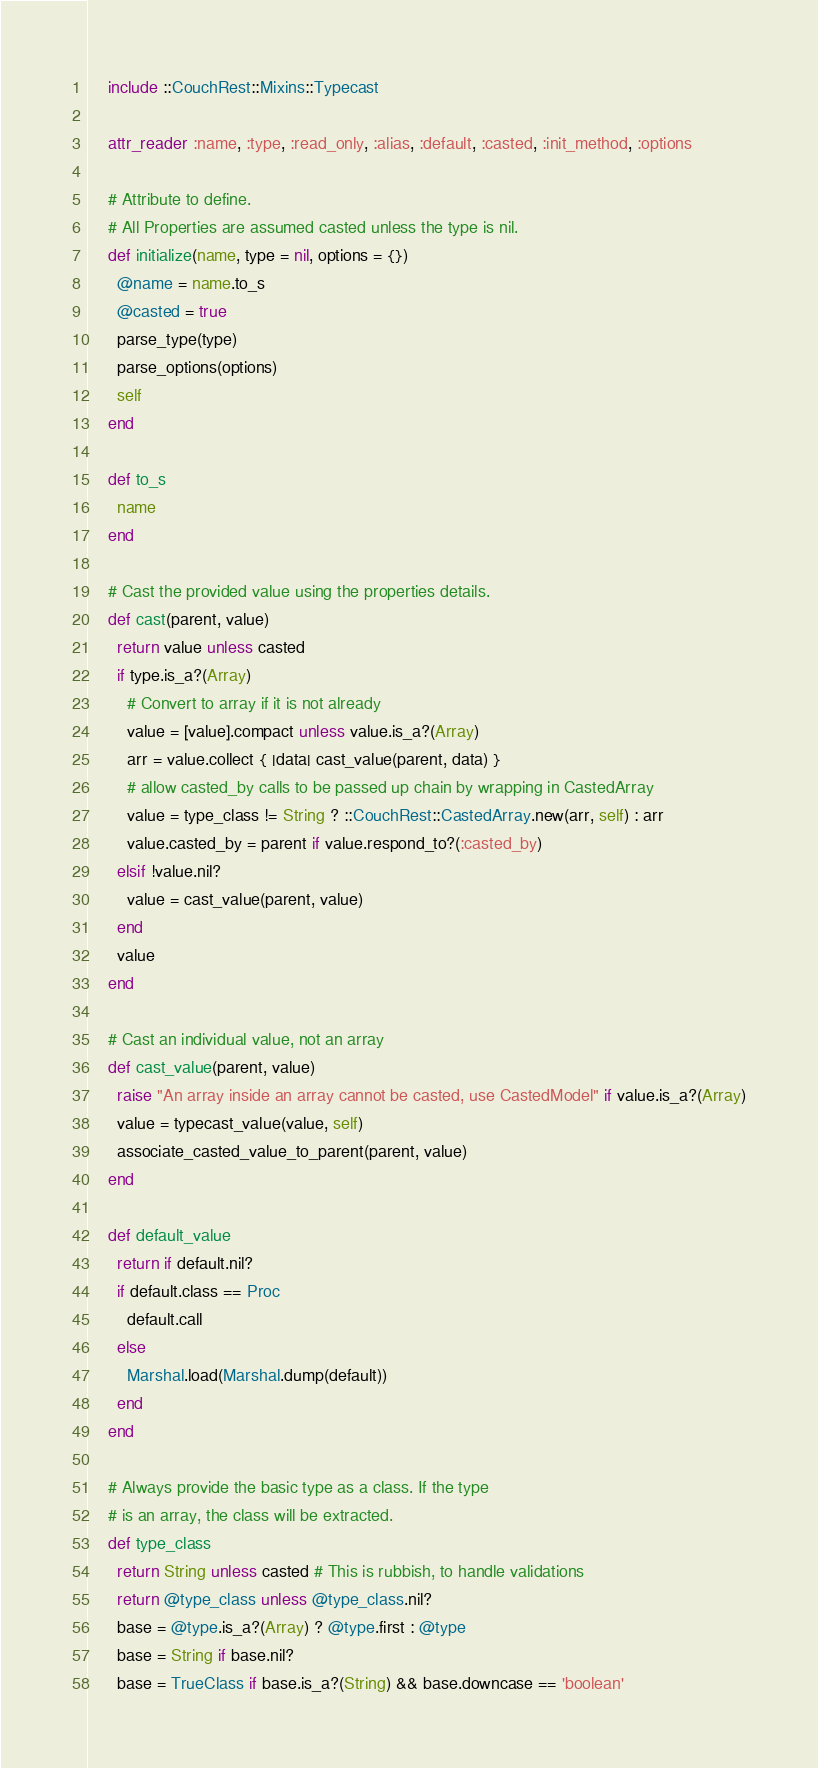Convert code to text. <code><loc_0><loc_0><loc_500><loc_500><_Ruby_>
    include ::CouchRest::Mixins::Typecast

    attr_reader :name, :type, :read_only, :alias, :default, :casted, :init_method, :options

    # Attribute to define.
    # All Properties are assumed casted unless the type is nil.
    def initialize(name, type = nil, options = {})
      @name = name.to_s
      @casted = true
      parse_type(type)
      parse_options(options)
      self
    end

    def to_s
      name
    end

    # Cast the provided value using the properties details.
    def cast(parent, value)
      return value unless casted
      if type.is_a?(Array)
        # Convert to array if it is not already
        value = [value].compact unless value.is_a?(Array)
        arr = value.collect { |data| cast_value(parent, data) }
        # allow casted_by calls to be passed up chain by wrapping in CastedArray
        value = type_class != String ? ::CouchRest::CastedArray.new(arr, self) : arr
        value.casted_by = parent if value.respond_to?(:casted_by)
      elsif !value.nil?
        value = cast_value(parent, value)
      end
      value
    end

    # Cast an individual value, not an array
    def cast_value(parent, value)
      raise "An array inside an array cannot be casted, use CastedModel" if value.is_a?(Array)
      value = typecast_value(value, self)
      associate_casted_value_to_parent(parent, value)
    end

    def default_value
      return if default.nil?
      if default.class == Proc
        default.call
      else
        Marshal.load(Marshal.dump(default))
      end
    end

    # Always provide the basic type as a class. If the type 
    # is an array, the class will be extracted.
    def type_class
      return String unless casted # This is rubbish, to handle validations
      return @type_class unless @type_class.nil?
      base = @type.is_a?(Array) ? @type.first : @type
      base = String if base.nil?
      base = TrueClass if base.is_a?(String) && base.downcase == 'boolean'</code> 